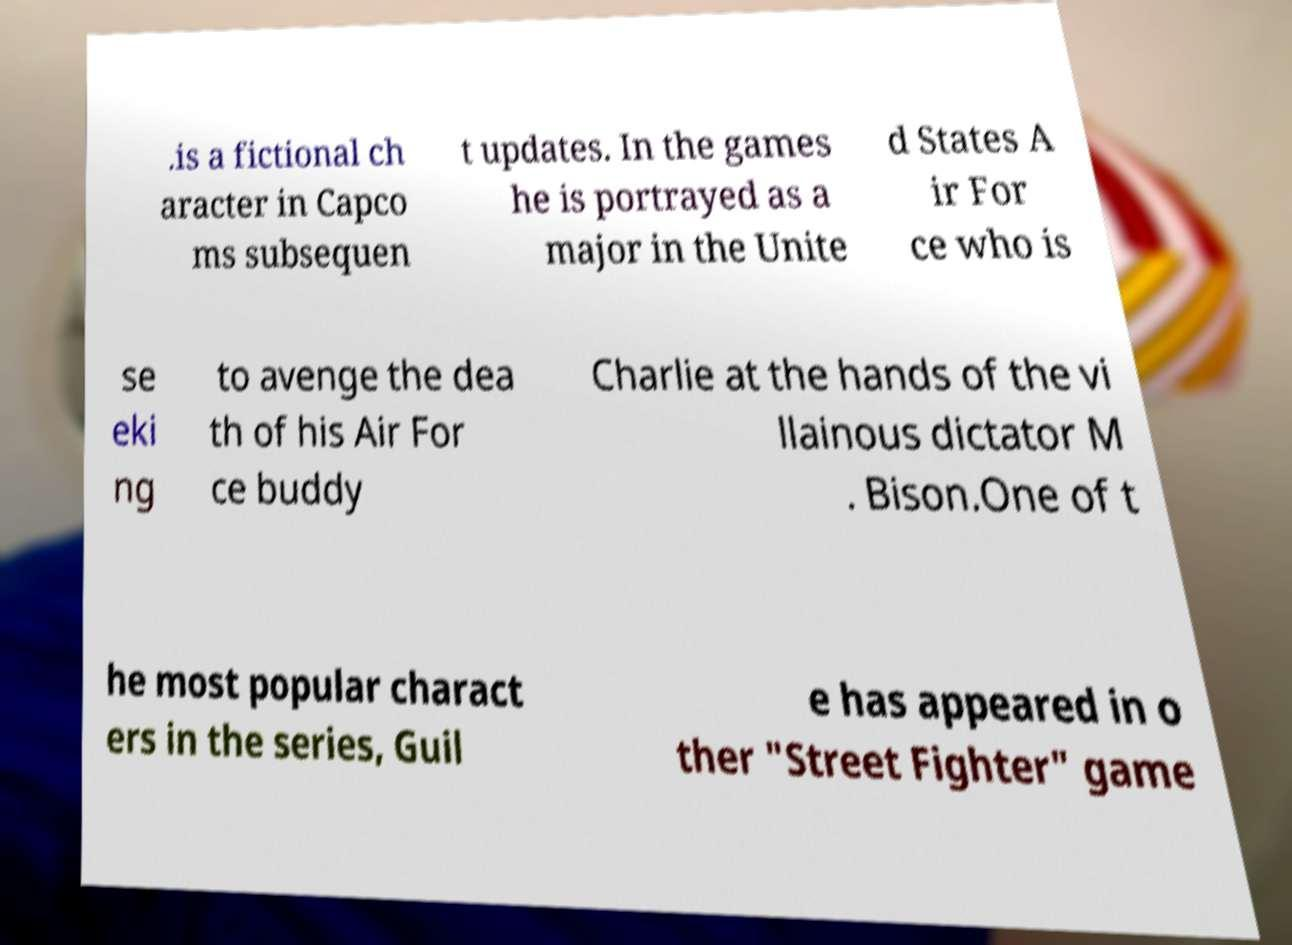I need the written content from this picture converted into text. Can you do that? .is a fictional ch aracter in Capco ms subsequen t updates. In the games he is portrayed as a major in the Unite d States A ir For ce who is se eki ng to avenge the dea th of his Air For ce buddy Charlie at the hands of the vi llainous dictator M . Bison.One of t he most popular charact ers in the series, Guil e has appeared in o ther "Street Fighter" game 